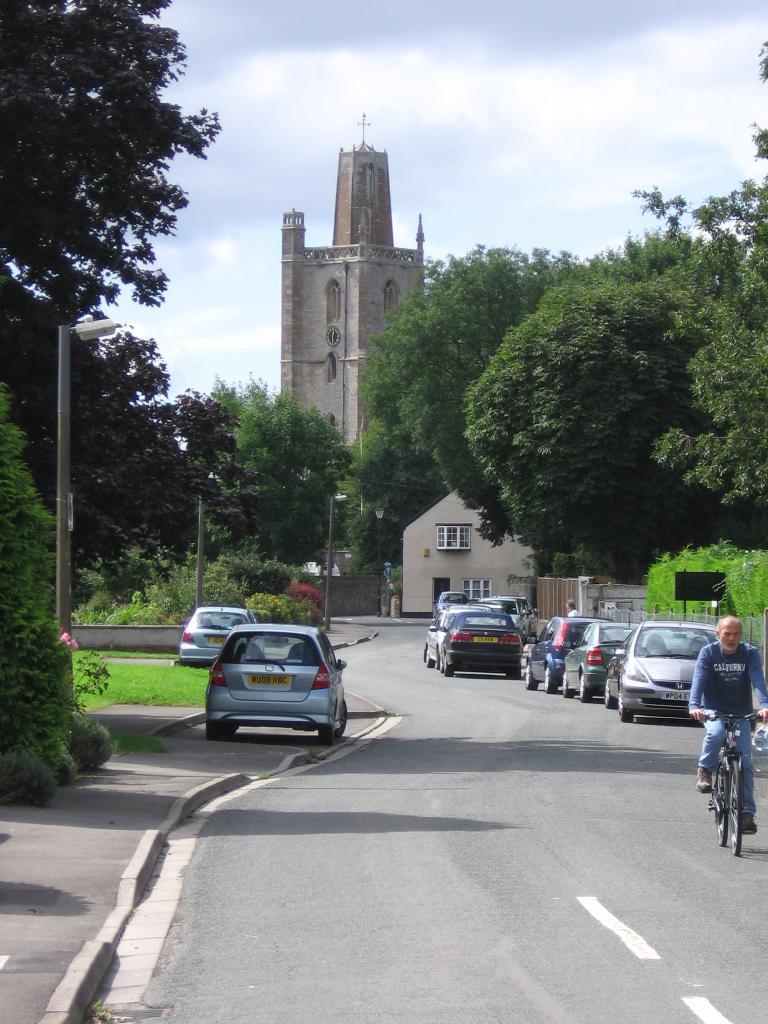In one or two sentences, can you explain what this image depicts? In this image we can see a few vehicles on the road, among them one person is riding a bicycle, there are some buildings, trees, plants, grass, poles, lights and fence, in the background we can see the sky. 